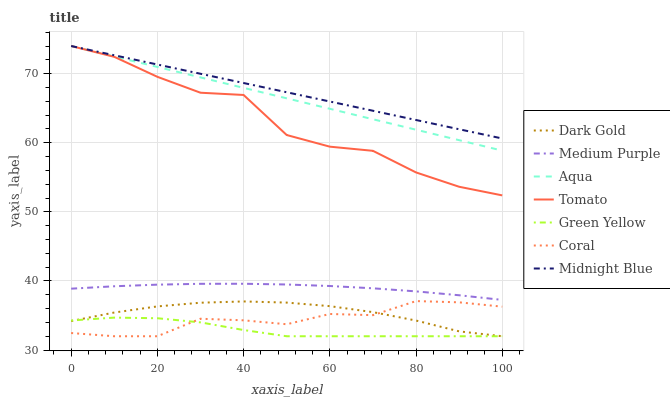Does Dark Gold have the minimum area under the curve?
Answer yes or no. No. Does Dark Gold have the maximum area under the curve?
Answer yes or no. No. Is Midnight Blue the smoothest?
Answer yes or no. No. Is Midnight Blue the roughest?
Answer yes or no. No. Does Midnight Blue have the lowest value?
Answer yes or no. No. Does Dark Gold have the highest value?
Answer yes or no. No. Is Green Yellow less than Tomato?
Answer yes or no. Yes. Is Medium Purple greater than Green Yellow?
Answer yes or no. Yes. Does Green Yellow intersect Tomato?
Answer yes or no. No. 